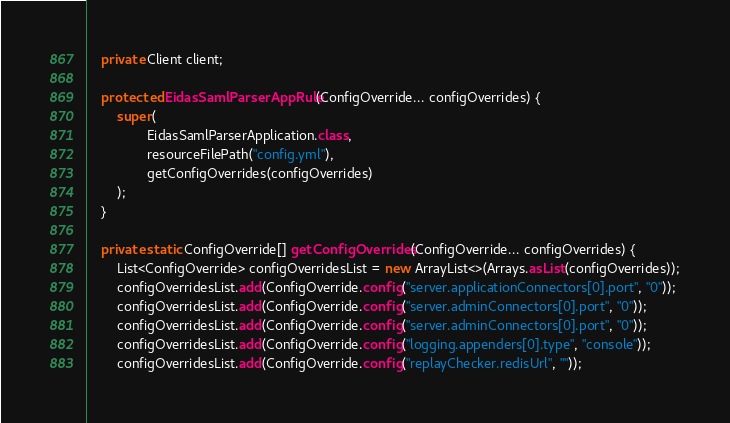Convert code to text. <code><loc_0><loc_0><loc_500><loc_500><_Java_>
    private Client client;

    protected EidasSamlParserAppRule(ConfigOverride... configOverrides) {
        super(
                EidasSamlParserApplication.class,
                resourceFilePath("config.yml"),
                getConfigOverrides(configOverrides)
        );
    }

    private static ConfigOverride[] getConfigOverrides(ConfigOverride... configOverrides) {
        List<ConfigOverride> configOverridesList = new ArrayList<>(Arrays.asList(configOverrides));
        configOverridesList.add(ConfigOverride.config("server.applicationConnectors[0].port", "0"));
        configOverridesList.add(ConfigOverride.config("server.adminConnectors[0].port", "0"));
        configOverridesList.add(ConfigOverride.config("server.adminConnectors[0].port", "0"));
        configOverridesList.add(ConfigOverride.config("logging.appenders[0].type", "console"));
        configOverridesList.add(ConfigOverride.config("replayChecker.redisUrl", ""));</code> 